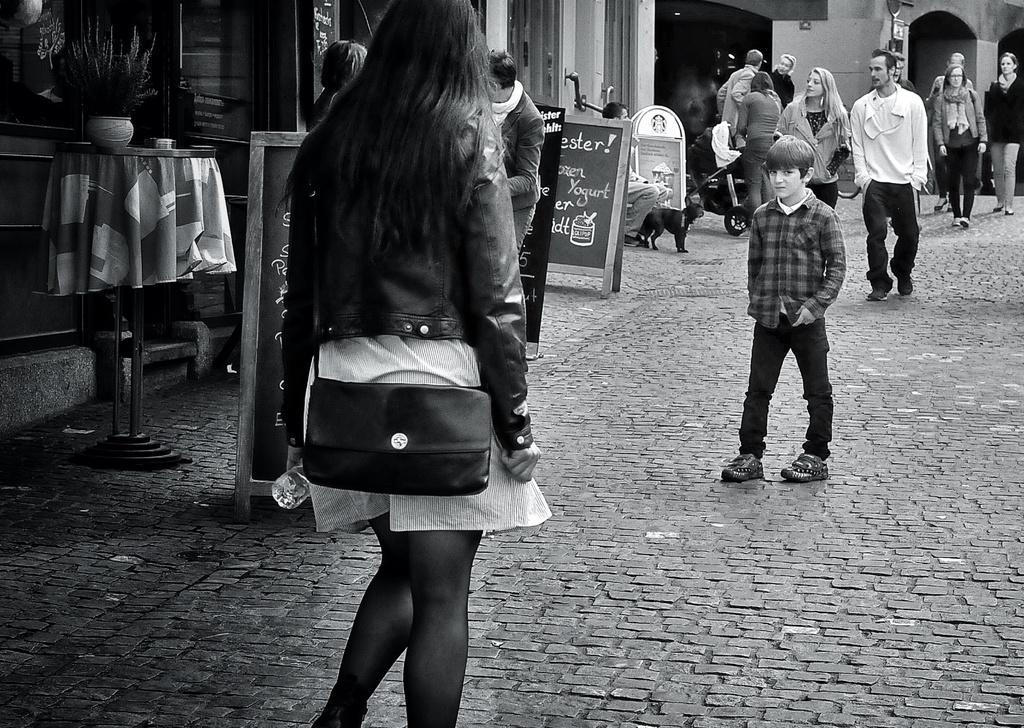Please provide a concise description of this image. On the road there are some people walking. A boy with the checks shirt is standing in the middle of the road. And to the footpath there are some posters. And we can also see animal. And a lady is carrying a stroller. And to the left corner there is a table with cloth. On the table there is a pot with plant. 